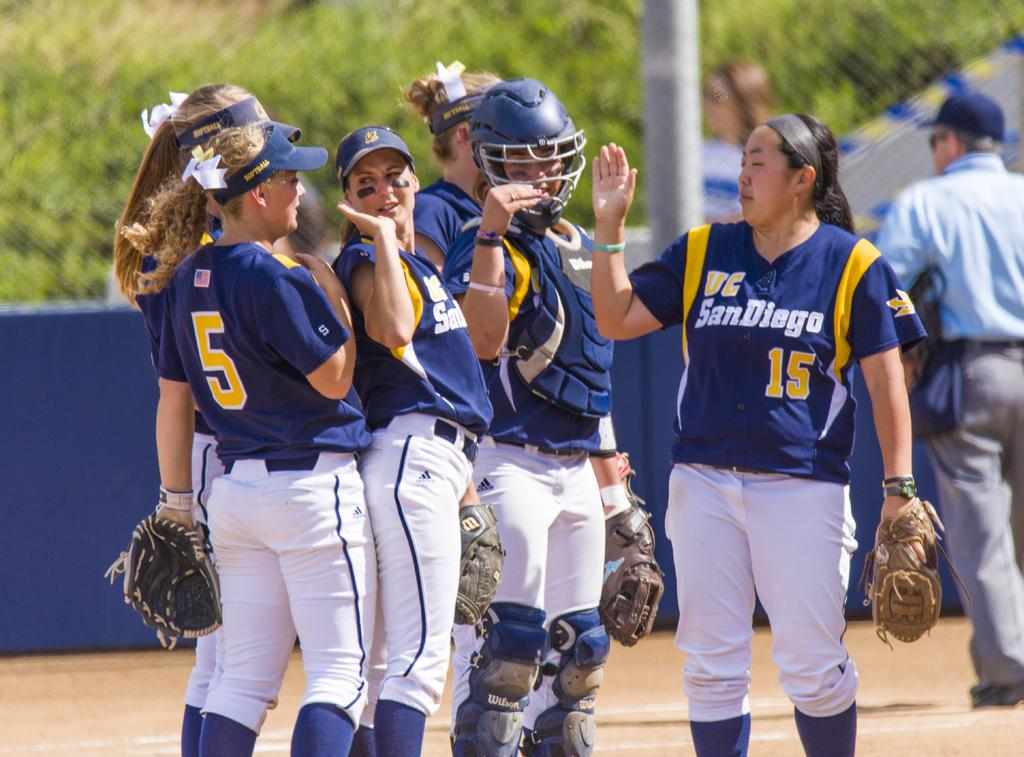<image>
Relay a brief, clear account of the picture shown. Baseball players in blue and gold uniforms with wording  VC San Diego giving eachother high fives. 